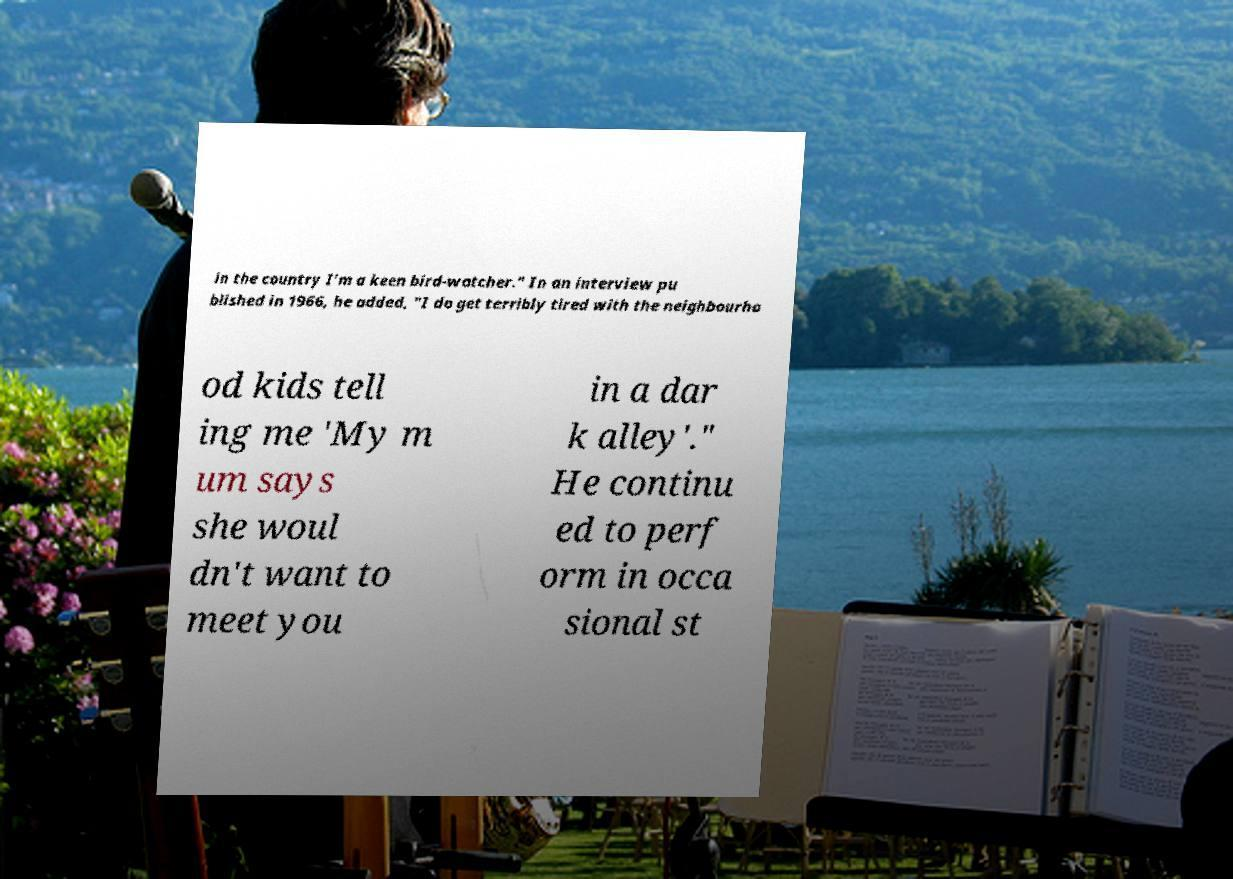Please read and relay the text visible in this image. What does it say? in the country I'm a keen bird-watcher." In an interview pu blished in 1966, he added, "I do get terribly tired with the neighbourho od kids tell ing me 'My m um says she woul dn't want to meet you in a dar k alley'." He continu ed to perf orm in occa sional st 